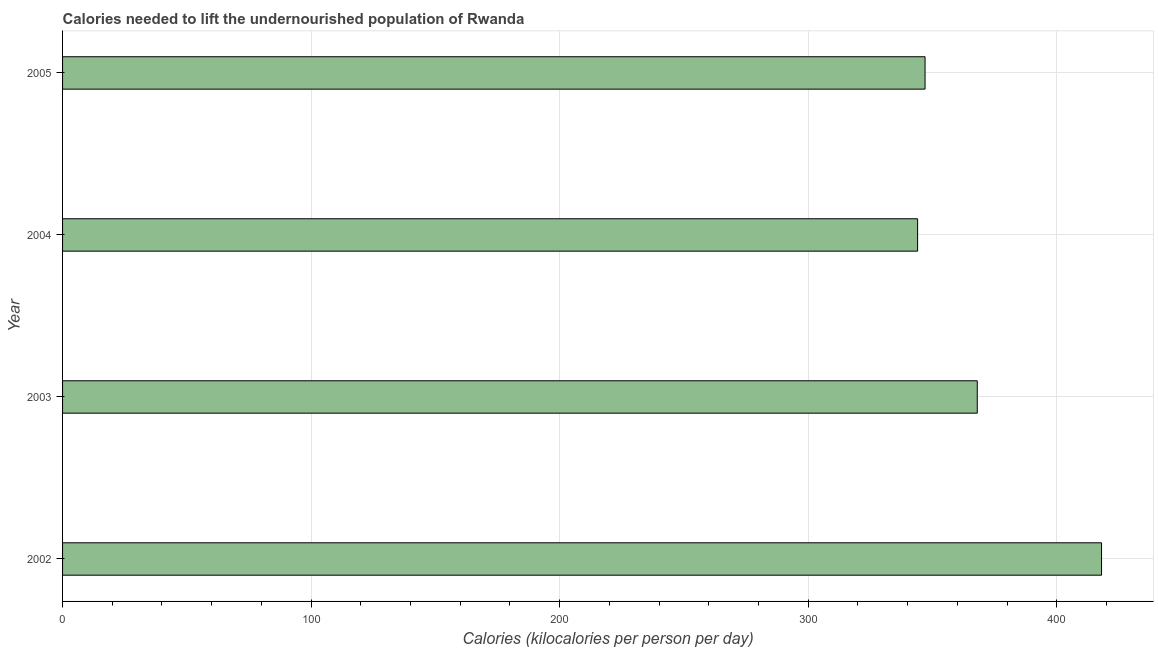What is the title of the graph?
Provide a succinct answer. Calories needed to lift the undernourished population of Rwanda. What is the label or title of the X-axis?
Your response must be concise. Calories (kilocalories per person per day). What is the depth of food deficit in 2005?
Make the answer very short. 347. Across all years, what is the maximum depth of food deficit?
Your response must be concise. 418. Across all years, what is the minimum depth of food deficit?
Offer a very short reply. 344. In which year was the depth of food deficit minimum?
Offer a very short reply. 2004. What is the sum of the depth of food deficit?
Offer a terse response. 1477. What is the average depth of food deficit per year?
Ensure brevity in your answer.  369. What is the median depth of food deficit?
Offer a very short reply. 357.5. In how many years, is the depth of food deficit greater than 380 kilocalories?
Your answer should be very brief. 1. Do a majority of the years between 2002 and 2003 (inclusive) have depth of food deficit greater than 280 kilocalories?
Offer a very short reply. Yes. What is the ratio of the depth of food deficit in 2003 to that in 2004?
Give a very brief answer. 1.07. Is the difference between the depth of food deficit in 2002 and 2005 greater than the difference between any two years?
Provide a succinct answer. No. What is the difference between the highest and the second highest depth of food deficit?
Offer a terse response. 50. Is the sum of the depth of food deficit in 2002 and 2003 greater than the maximum depth of food deficit across all years?
Keep it short and to the point. Yes. Are the values on the major ticks of X-axis written in scientific E-notation?
Keep it short and to the point. No. What is the Calories (kilocalories per person per day) in 2002?
Your answer should be compact. 418. What is the Calories (kilocalories per person per day) in 2003?
Ensure brevity in your answer.  368. What is the Calories (kilocalories per person per day) of 2004?
Your answer should be compact. 344. What is the Calories (kilocalories per person per day) of 2005?
Make the answer very short. 347. What is the difference between the Calories (kilocalories per person per day) in 2002 and 2003?
Ensure brevity in your answer.  50. What is the difference between the Calories (kilocalories per person per day) in 2002 and 2005?
Offer a very short reply. 71. What is the difference between the Calories (kilocalories per person per day) in 2003 and 2004?
Ensure brevity in your answer.  24. What is the ratio of the Calories (kilocalories per person per day) in 2002 to that in 2003?
Make the answer very short. 1.14. What is the ratio of the Calories (kilocalories per person per day) in 2002 to that in 2004?
Give a very brief answer. 1.22. What is the ratio of the Calories (kilocalories per person per day) in 2002 to that in 2005?
Make the answer very short. 1.21. What is the ratio of the Calories (kilocalories per person per day) in 2003 to that in 2004?
Ensure brevity in your answer.  1.07. What is the ratio of the Calories (kilocalories per person per day) in 2003 to that in 2005?
Provide a short and direct response. 1.06. 